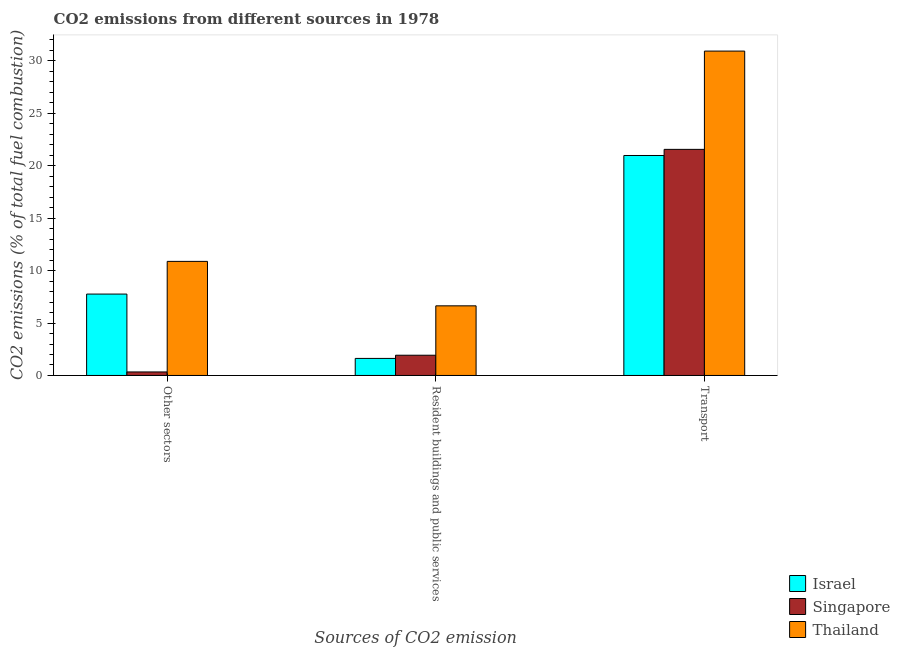How many different coloured bars are there?
Keep it short and to the point. 3. How many groups of bars are there?
Ensure brevity in your answer.  3. How many bars are there on the 2nd tick from the left?
Ensure brevity in your answer.  3. How many bars are there on the 1st tick from the right?
Ensure brevity in your answer.  3. What is the label of the 2nd group of bars from the left?
Make the answer very short. Resident buildings and public services. What is the percentage of co2 emissions from transport in Israel?
Make the answer very short. 20.98. Across all countries, what is the maximum percentage of co2 emissions from other sectors?
Offer a very short reply. 10.88. Across all countries, what is the minimum percentage of co2 emissions from other sectors?
Your response must be concise. 0.34. In which country was the percentage of co2 emissions from resident buildings and public services maximum?
Ensure brevity in your answer.  Thailand. In which country was the percentage of co2 emissions from transport minimum?
Your answer should be very brief. Israel. What is the total percentage of co2 emissions from other sectors in the graph?
Give a very brief answer. 18.97. What is the difference between the percentage of co2 emissions from resident buildings and public services in Thailand and that in Israel?
Keep it short and to the point. 5.01. What is the difference between the percentage of co2 emissions from other sectors in Thailand and the percentage of co2 emissions from resident buildings and public services in Singapore?
Give a very brief answer. 8.95. What is the average percentage of co2 emissions from other sectors per country?
Offer a terse response. 6.32. What is the difference between the percentage of co2 emissions from other sectors and percentage of co2 emissions from transport in Singapore?
Provide a short and direct response. -21.22. What is the ratio of the percentage of co2 emissions from transport in Israel to that in Thailand?
Give a very brief answer. 0.68. What is the difference between the highest and the second highest percentage of co2 emissions from transport?
Your response must be concise. 9.37. What is the difference between the highest and the lowest percentage of co2 emissions from transport?
Make the answer very short. 9.96. What does the 3rd bar from the left in Transport represents?
Your response must be concise. Thailand. What does the 2nd bar from the right in Transport represents?
Provide a succinct answer. Singapore. Is it the case that in every country, the sum of the percentage of co2 emissions from other sectors and percentage of co2 emissions from resident buildings and public services is greater than the percentage of co2 emissions from transport?
Your response must be concise. No. How many bars are there?
Give a very brief answer. 9. Are all the bars in the graph horizontal?
Make the answer very short. No. How many countries are there in the graph?
Provide a succinct answer. 3. Are the values on the major ticks of Y-axis written in scientific E-notation?
Provide a succinct answer. No. Does the graph contain any zero values?
Keep it short and to the point. No. Does the graph contain grids?
Make the answer very short. No. Where does the legend appear in the graph?
Keep it short and to the point. Bottom right. What is the title of the graph?
Provide a succinct answer. CO2 emissions from different sources in 1978. What is the label or title of the X-axis?
Ensure brevity in your answer.  Sources of CO2 emission. What is the label or title of the Y-axis?
Your response must be concise. CO2 emissions (% of total fuel combustion). What is the CO2 emissions (% of total fuel combustion) in Israel in Other sectors?
Your answer should be compact. 7.76. What is the CO2 emissions (% of total fuel combustion) of Singapore in Other sectors?
Make the answer very short. 0.34. What is the CO2 emissions (% of total fuel combustion) in Thailand in Other sectors?
Offer a very short reply. 10.88. What is the CO2 emissions (% of total fuel combustion) in Israel in Resident buildings and public services?
Your answer should be compact. 1.63. What is the CO2 emissions (% of total fuel combustion) of Singapore in Resident buildings and public services?
Ensure brevity in your answer.  1.93. What is the CO2 emissions (% of total fuel combustion) in Thailand in Resident buildings and public services?
Your answer should be very brief. 6.64. What is the CO2 emissions (% of total fuel combustion) of Israel in Transport?
Your answer should be very brief. 20.98. What is the CO2 emissions (% of total fuel combustion) of Singapore in Transport?
Keep it short and to the point. 21.56. What is the CO2 emissions (% of total fuel combustion) of Thailand in Transport?
Provide a short and direct response. 30.93. Across all Sources of CO2 emission, what is the maximum CO2 emissions (% of total fuel combustion) of Israel?
Give a very brief answer. 20.98. Across all Sources of CO2 emission, what is the maximum CO2 emissions (% of total fuel combustion) in Singapore?
Provide a short and direct response. 21.56. Across all Sources of CO2 emission, what is the maximum CO2 emissions (% of total fuel combustion) in Thailand?
Give a very brief answer. 30.93. Across all Sources of CO2 emission, what is the minimum CO2 emissions (% of total fuel combustion) in Israel?
Make the answer very short. 1.63. Across all Sources of CO2 emission, what is the minimum CO2 emissions (% of total fuel combustion) of Singapore?
Keep it short and to the point. 0.34. Across all Sources of CO2 emission, what is the minimum CO2 emissions (% of total fuel combustion) in Thailand?
Provide a succinct answer. 6.64. What is the total CO2 emissions (% of total fuel combustion) of Israel in the graph?
Ensure brevity in your answer.  30.36. What is the total CO2 emissions (% of total fuel combustion) in Singapore in the graph?
Ensure brevity in your answer.  23.83. What is the total CO2 emissions (% of total fuel combustion) of Thailand in the graph?
Offer a terse response. 48.45. What is the difference between the CO2 emissions (% of total fuel combustion) in Israel in Other sectors and that in Resident buildings and public services?
Make the answer very short. 6.14. What is the difference between the CO2 emissions (% of total fuel combustion) in Singapore in Other sectors and that in Resident buildings and public services?
Your answer should be very brief. -1.59. What is the difference between the CO2 emissions (% of total fuel combustion) in Thailand in Other sectors and that in Resident buildings and public services?
Your response must be concise. 4.24. What is the difference between the CO2 emissions (% of total fuel combustion) in Israel in Other sectors and that in Transport?
Your answer should be compact. -13.21. What is the difference between the CO2 emissions (% of total fuel combustion) in Singapore in Other sectors and that in Transport?
Give a very brief answer. -21.22. What is the difference between the CO2 emissions (% of total fuel combustion) in Thailand in Other sectors and that in Transport?
Ensure brevity in your answer.  -20.05. What is the difference between the CO2 emissions (% of total fuel combustion) in Israel in Resident buildings and public services and that in Transport?
Give a very brief answer. -19.35. What is the difference between the CO2 emissions (% of total fuel combustion) of Singapore in Resident buildings and public services and that in Transport?
Provide a succinct answer. -19.63. What is the difference between the CO2 emissions (% of total fuel combustion) of Thailand in Resident buildings and public services and that in Transport?
Make the answer very short. -24.29. What is the difference between the CO2 emissions (% of total fuel combustion) of Israel in Other sectors and the CO2 emissions (% of total fuel combustion) of Singapore in Resident buildings and public services?
Give a very brief answer. 5.83. What is the difference between the CO2 emissions (% of total fuel combustion) in Israel in Other sectors and the CO2 emissions (% of total fuel combustion) in Thailand in Resident buildings and public services?
Ensure brevity in your answer.  1.12. What is the difference between the CO2 emissions (% of total fuel combustion) in Singapore in Other sectors and the CO2 emissions (% of total fuel combustion) in Thailand in Resident buildings and public services?
Offer a terse response. -6.3. What is the difference between the CO2 emissions (% of total fuel combustion) of Israel in Other sectors and the CO2 emissions (% of total fuel combustion) of Singapore in Transport?
Your response must be concise. -13.8. What is the difference between the CO2 emissions (% of total fuel combustion) in Israel in Other sectors and the CO2 emissions (% of total fuel combustion) in Thailand in Transport?
Your answer should be very brief. -23.17. What is the difference between the CO2 emissions (% of total fuel combustion) of Singapore in Other sectors and the CO2 emissions (% of total fuel combustion) of Thailand in Transport?
Keep it short and to the point. -30.6. What is the difference between the CO2 emissions (% of total fuel combustion) of Israel in Resident buildings and public services and the CO2 emissions (% of total fuel combustion) of Singapore in Transport?
Make the answer very short. -19.93. What is the difference between the CO2 emissions (% of total fuel combustion) of Israel in Resident buildings and public services and the CO2 emissions (% of total fuel combustion) of Thailand in Transport?
Provide a short and direct response. -29.31. What is the difference between the CO2 emissions (% of total fuel combustion) in Singapore in Resident buildings and public services and the CO2 emissions (% of total fuel combustion) in Thailand in Transport?
Your response must be concise. -29. What is the average CO2 emissions (% of total fuel combustion) of Israel per Sources of CO2 emission?
Provide a succinct answer. 10.12. What is the average CO2 emissions (% of total fuel combustion) in Singapore per Sources of CO2 emission?
Your response must be concise. 7.94. What is the average CO2 emissions (% of total fuel combustion) in Thailand per Sources of CO2 emission?
Your answer should be compact. 16.15. What is the difference between the CO2 emissions (% of total fuel combustion) in Israel and CO2 emissions (% of total fuel combustion) in Singapore in Other sectors?
Offer a terse response. 7.43. What is the difference between the CO2 emissions (% of total fuel combustion) in Israel and CO2 emissions (% of total fuel combustion) in Thailand in Other sectors?
Your answer should be very brief. -3.12. What is the difference between the CO2 emissions (% of total fuel combustion) in Singapore and CO2 emissions (% of total fuel combustion) in Thailand in Other sectors?
Your response must be concise. -10.54. What is the difference between the CO2 emissions (% of total fuel combustion) in Israel and CO2 emissions (% of total fuel combustion) in Singapore in Resident buildings and public services?
Provide a succinct answer. -0.3. What is the difference between the CO2 emissions (% of total fuel combustion) in Israel and CO2 emissions (% of total fuel combustion) in Thailand in Resident buildings and public services?
Your answer should be compact. -5.01. What is the difference between the CO2 emissions (% of total fuel combustion) in Singapore and CO2 emissions (% of total fuel combustion) in Thailand in Resident buildings and public services?
Offer a very short reply. -4.71. What is the difference between the CO2 emissions (% of total fuel combustion) of Israel and CO2 emissions (% of total fuel combustion) of Singapore in Transport?
Offer a very short reply. -0.58. What is the difference between the CO2 emissions (% of total fuel combustion) of Israel and CO2 emissions (% of total fuel combustion) of Thailand in Transport?
Keep it short and to the point. -9.96. What is the difference between the CO2 emissions (% of total fuel combustion) of Singapore and CO2 emissions (% of total fuel combustion) of Thailand in Transport?
Your answer should be compact. -9.37. What is the ratio of the CO2 emissions (% of total fuel combustion) of Israel in Other sectors to that in Resident buildings and public services?
Your answer should be very brief. 4.77. What is the ratio of the CO2 emissions (% of total fuel combustion) of Singapore in Other sectors to that in Resident buildings and public services?
Offer a terse response. 0.17. What is the ratio of the CO2 emissions (% of total fuel combustion) of Thailand in Other sectors to that in Resident buildings and public services?
Your answer should be compact. 1.64. What is the ratio of the CO2 emissions (% of total fuel combustion) in Israel in Other sectors to that in Transport?
Offer a terse response. 0.37. What is the ratio of the CO2 emissions (% of total fuel combustion) of Singapore in Other sectors to that in Transport?
Provide a short and direct response. 0.02. What is the ratio of the CO2 emissions (% of total fuel combustion) of Thailand in Other sectors to that in Transport?
Make the answer very short. 0.35. What is the ratio of the CO2 emissions (% of total fuel combustion) in Israel in Resident buildings and public services to that in Transport?
Keep it short and to the point. 0.08. What is the ratio of the CO2 emissions (% of total fuel combustion) of Singapore in Resident buildings and public services to that in Transport?
Your response must be concise. 0.09. What is the ratio of the CO2 emissions (% of total fuel combustion) in Thailand in Resident buildings and public services to that in Transport?
Give a very brief answer. 0.21. What is the difference between the highest and the second highest CO2 emissions (% of total fuel combustion) of Israel?
Offer a very short reply. 13.21. What is the difference between the highest and the second highest CO2 emissions (% of total fuel combustion) in Singapore?
Make the answer very short. 19.63. What is the difference between the highest and the second highest CO2 emissions (% of total fuel combustion) in Thailand?
Provide a short and direct response. 20.05. What is the difference between the highest and the lowest CO2 emissions (% of total fuel combustion) in Israel?
Your answer should be compact. 19.35. What is the difference between the highest and the lowest CO2 emissions (% of total fuel combustion) in Singapore?
Keep it short and to the point. 21.22. What is the difference between the highest and the lowest CO2 emissions (% of total fuel combustion) of Thailand?
Your response must be concise. 24.29. 